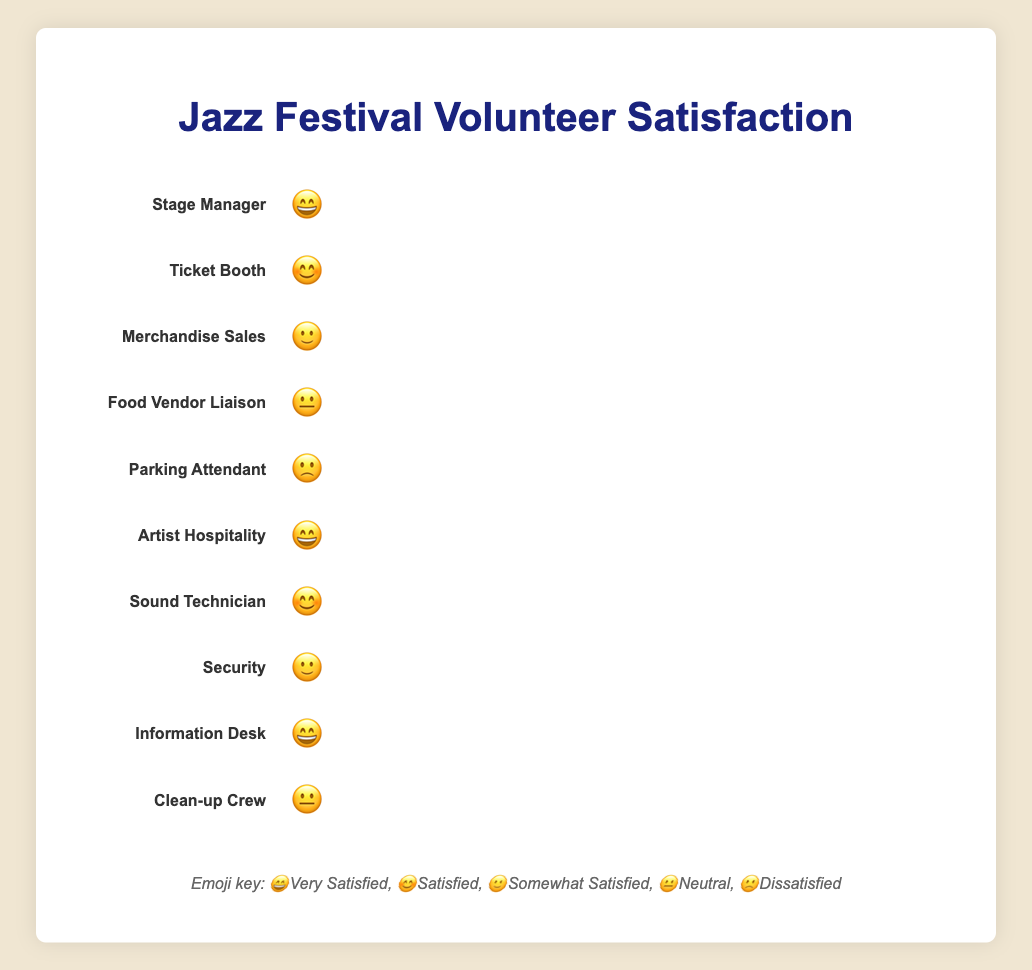How many roles are represented in the chart? The chart displays separate bars for each role, so by counting these bars, we find there are ten.
Answer: Ten Which role has the highest level of volunteer satisfaction? Looking at the emojis, "Stage Manager", "Artist Hospitality", and "Information Desk" roles are marked with 😄, indicating the highest level of satisfaction.
Answer: Stage Manager, Artist Hospitality, Information Desk Which role shows the least satisfaction level? By scanning the chart, we see that the "Parking Attendant" role is marked with 🙁, indicating the least satisfaction.
Answer: Parking Attendant Are there more roles with satisfaction levels 😄 and 😊, or with 🙂, 😐, and 🙁 combined? Counting the roles: 😄 (4 roles) and 😊 (2 roles) total 6. Roles with 🙂 (2), 😐 (2), and 🙁 (1) total 5.
Answer: More roles with 😄 and 😊 Which roles have a neutral level of volunteer satisfaction? By looking at the neutral emoji 😐, we find "Food Vendor Liaison" and "Clean-up Crew" have this level.
Answer: Food Vendor Liaison, Clean-up Crew How does the satisfaction level of "Security" compare to "Ticket Booth"? The "Security" role has 🙂 (Somewhat Satisfied) and "Ticket Booth" has 😊 (Satisfied). Thus, the satisfaction level of "Security" is lower.
Answer: Security is lower What is the average satisfaction level for all the roles? Assigning numeric values to emojis (😄=5, 😊=4, 🙂=3, 😐=2, 🙁=1): the total value is (5+4+3+2+1+5+4+3+5+2)=34. With 10 roles, the average is 34/10=3.4, closest to "😊".
Answer: 😊 What proportion of roles are either "Very Satisfied" or "Satisfied"? The roles with 😄 are 4 and with 😊 are 2, making a total of 6 out of 10 roles. So the proportion is 6/10 or 60%.
Answer: 60% Which role has a better satisfaction level: "Sound Technician" or "Merchandise Sales"? "Sound Technician" has 😊 (Satisfied) while "Merchandise Sales" has 🙂 (Somewhat Satisfied). Thus, "Sound Technician" has a better level.
Answer: Sound Technician 